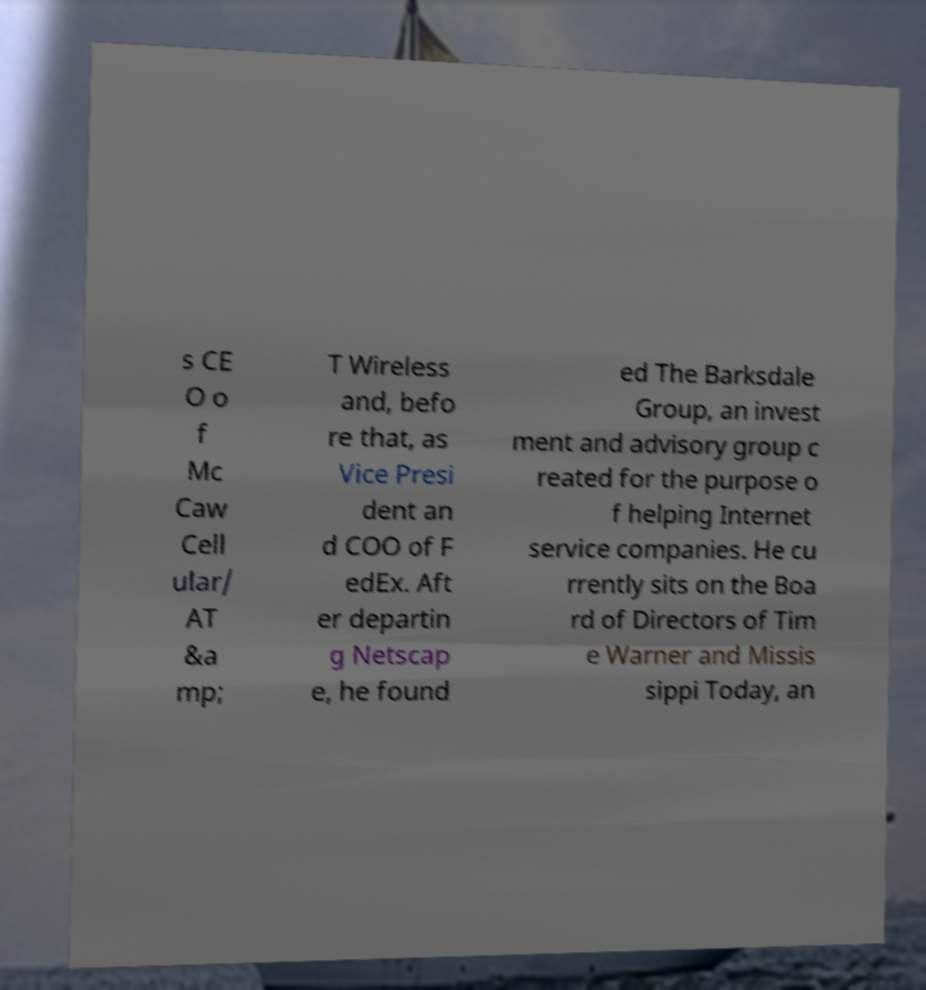What messages or text are displayed in this image? I need them in a readable, typed format. s CE O o f Mc Caw Cell ular/ AT &a mp; T Wireless and, befo re that, as Vice Presi dent an d COO of F edEx. Aft er departin g Netscap e, he found ed The Barksdale Group, an invest ment and advisory group c reated for the purpose o f helping Internet service companies. He cu rrently sits on the Boa rd of Directors of Tim e Warner and Missis sippi Today, an 